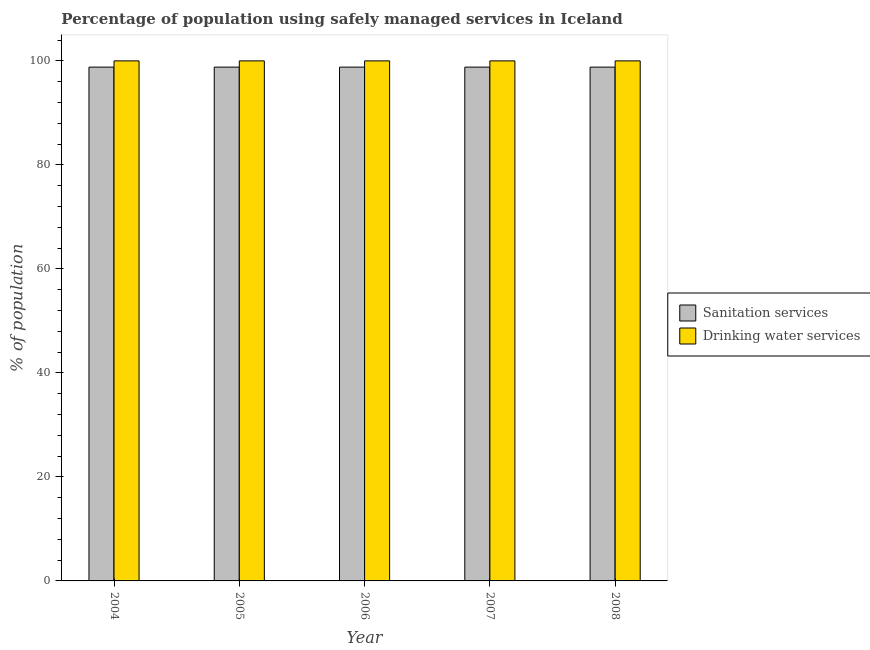How many different coloured bars are there?
Provide a succinct answer. 2. Are the number of bars per tick equal to the number of legend labels?
Offer a very short reply. Yes. How many bars are there on the 4th tick from the left?
Provide a succinct answer. 2. How many bars are there on the 3rd tick from the right?
Ensure brevity in your answer.  2. What is the label of the 5th group of bars from the left?
Make the answer very short. 2008. What is the percentage of population who used drinking water services in 2006?
Give a very brief answer. 100. Across all years, what is the maximum percentage of population who used sanitation services?
Ensure brevity in your answer.  98.8. Across all years, what is the minimum percentage of population who used drinking water services?
Give a very brief answer. 100. What is the total percentage of population who used drinking water services in the graph?
Your answer should be compact. 500. What is the difference between the percentage of population who used drinking water services in 2006 and the percentage of population who used sanitation services in 2004?
Ensure brevity in your answer.  0. In how many years, is the percentage of population who used drinking water services greater than 100 %?
Make the answer very short. 0. Is the difference between the percentage of population who used drinking water services in 2004 and 2006 greater than the difference between the percentage of population who used sanitation services in 2004 and 2006?
Provide a short and direct response. No. In how many years, is the percentage of population who used sanitation services greater than the average percentage of population who used sanitation services taken over all years?
Offer a terse response. 0. Is the sum of the percentage of population who used sanitation services in 2006 and 2008 greater than the maximum percentage of population who used drinking water services across all years?
Offer a very short reply. Yes. What does the 2nd bar from the left in 2007 represents?
Your answer should be very brief. Drinking water services. What does the 1st bar from the right in 2005 represents?
Ensure brevity in your answer.  Drinking water services. Are all the bars in the graph horizontal?
Provide a succinct answer. No. Are the values on the major ticks of Y-axis written in scientific E-notation?
Make the answer very short. No. Does the graph contain any zero values?
Provide a succinct answer. No. Does the graph contain grids?
Provide a short and direct response. No. How many legend labels are there?
Offer a terse response. 2. What is the title of the graph?
Offer a terse response. Percentage of population using safely managed services in Iceland. What is the label or title of the Y-axis?
Make the answer very short. % of population. What is the % of population of Sanitation services in 2004?
Your answer should be compact. 98.8. What is the % of population of Sanitation services in 2005?
Provide a short and direct response. 98.8. What is the % of population of Drinking water services in 2005?
Provide a succinct answer. 100. What is the % of population of Sanitation services in 2006?
Ensure brevity in your answer.  98.8. What is the % of population in Sanitation services in 2007?
Your answer should be compact. 98.8. What is the % of population of Drinking water services in 2007?
Offer a very short reply. 100. What is the % of population in Sanitation services in 2008?
Offer a very short reply. 98.8. Across all years, what is the maximum % of population of Sanitation services?
Your response must be concise. 98.8. Across all years, what is the minimum % of population of Sanitation services?
Provide a short and direct response. 98.8. Across all years, what is the minimum % of population in Drinking water services?
Make the answer very short. 100. What is the total % of population of Sanitation services in the graph?
Keep it short and to the point. 494. What is the total % of population of Drinking water services in the graph?
Your answer should be compact. 500. What is the difference between the % of population in Sanitation services in 2004 and that in 2005?
Your answer should be very brief. 0. What is the difference between the % of population in Drinking water services in 2004 and that in 2005?
Ensure brevity in your answer.  0. What is the difference between the % of population in Sanitation services in 2004 and that in 2006?
Offer a terse response. 0. What is the difference between the % of population in Sanitation services in 2004 and that in 2007?
Provide a short and direct response. 0. What is the difference between the % of population of Sanitation services in 2004 and that in 2008?
Your answer should be very brief. 0. What is the difference between the % of population in Drinking water services in 2004 and that in 2008?
Your response must be concise. 0. What is the difference between the % of population of Sanitation services in 2005 and that in 2007?
Offer a very short reply. 0. What is the difference between the % of population in Sanitation services in 2005 and that in 2008?
Your response must be concise. 0. What is the difference between the % of population in Sanitation services in 2007 and that in 2008?
Make the answer very short. 0. What is the difference between the % of population in Sanitation services in 2004 and the % of population in Drinking water services in 2005?
Provide a short and direct response. -1.2. What is the difference between the % of population in Sanitation services in 2004 and the % of population in Drinking water services in 2007?
Your response must be concise. -1.2. What is the difference between the % of population in Sanitation services in 2005 and the % of population in Drinking water services in 2006?
Keep it short and to the point. -1.2. What is the difference between the % of population of Sanitation services in 2005 and the % of population of Drinking water services in 2007?
Your answer should be very brief. -1.2. What is the difference between the % of population of Sanitation services in 2006 and the % of population of Drinking water services in 2008?
Your response must be concise. -1.2. What is the difference between the % of population of Sanitation services in 2007 and the % of population of Drinking water services in 2008?
Ensure brevity in your answer.  -1.2. What is the average % of population of Sanitation services per year?
Provide a succinct answer. 98.8. In the year 2007, what is the difference between the % of population of Sanitation services and % of population of Drinking water services?
Your response must be concise. -1.2. What is the ratio of the % of population of Sanitation services in 2004 to that in 2006?
Your answer should be compact. 1. What is the ratio of the % of population in Sanitation services in 2004 to that in 2008?
Keep it short and to the point. 1. What is the ratio of the % of population of Drinking water services in 2004 to that in 2008?
Provide a short and direct response. 1. What is the ratio of the % of population of Sanitation services in 2005 to that in 2006?
Keep it short and to the point. 1. What is the ratio of the % of population in Drinking water services in 2005 to that in 2007?
Ensure brevity in your answer.  1. What is the ratio of the % of population in Sanitation services in 2006 to that in 2007?
Your answer should be very brief. 1. What is the ratio of the % of population of Sanitation services in 2006 to that in 2008?
Your response must be concise. 1. What is the ratio of the % of population in Sanitation services in 2007 to that in 2008?
Your answer should be compact. 1. What is the ratio of the % of population in Drinking water services in 2007 to that in 2008?
Give a very brief answer. 1. What is the difference between the highest and the second highest % of population of Sanitation services?
Keep it short and to the point. 0. What is the difference between the highest and the lowest % of population in Drinking water services?
Ensure brevity in your answer.  0. 